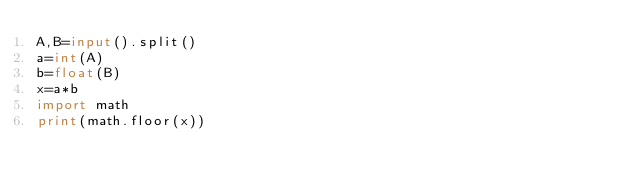Convert code to text. <code><loc_0><loc_0><loc_500><loc_500><_Python_>A,B=input().split()
a=int(A)
b=float(B)
x=a*b
import math
print(math.floor(x))</code> 